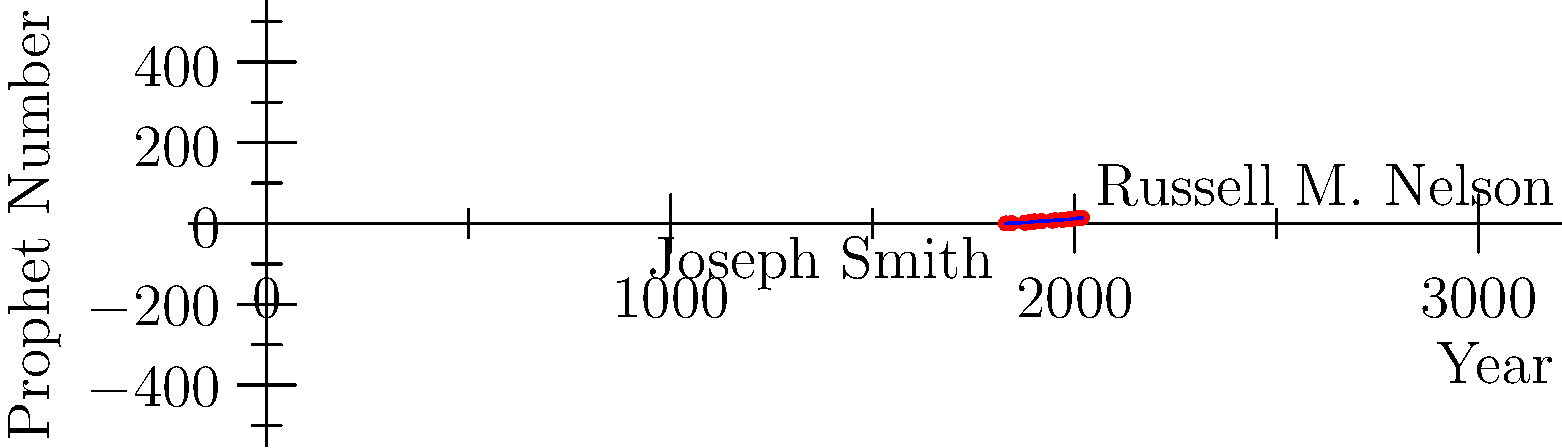Based on the timeline of Mormon prophets shown in the graph, approximately how many years passed between the calling of Joseph Smith as the first prophet and the calling of Russell M. Nelson as the current prophet? To determine the number of years between Joseph Smith and Russell M. Nelson, we need to follow these steps:

1. Identify the year Joseph Smith became the first prophet:
   From the graph, we can see that the first data point corresponds to 1830.

2. Identify the year Russell M. Nelson became the prophet:
   The last data point on the graph shows 2018 for the 15th prophet.

3. Calculate the difference between these years:
   2018 - 1830 = 188 years

This timeline represents the succession of prophets in the Church of Jesus Christ of Latter-day Saints, starting with Joseph Smith in 1830 and continuing to the present day with Russell M. Nelson, who became the prophet in 2018.

The graph shows the linear progression of prophets over time, with each new point representing a change in church leadership. This visual representation helps us understand the historical continuity of prophetic succession in the Mormon faith, which is a fundamental aspect of the church's structure and beliefs.
Answer: 188 years 